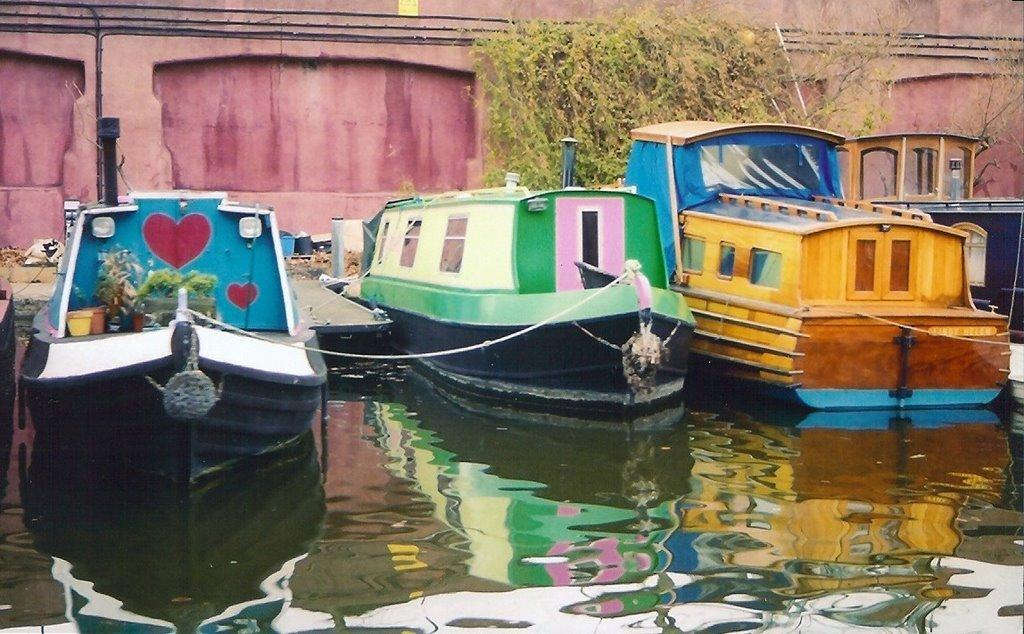What types of vehicles are in the water in the image? There are different colored boats in the water in the image. What can be seen on the land in the image? There is a footpath in the image. Are there any plants visible in the image? Yes, there is a plant in the image? What type of wire is being used to secure the boats in the image? There is no wire visible in the image; the boats are simply floating in the water. 